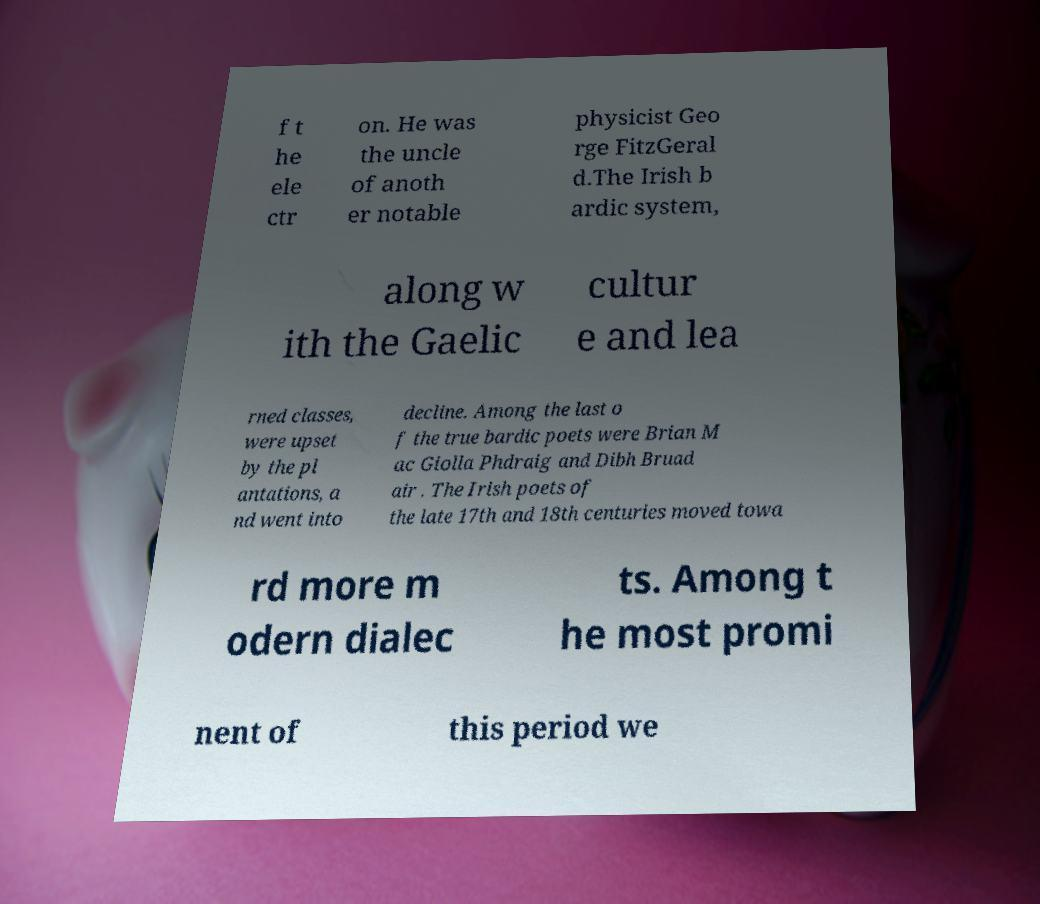For documentation purposes, I need the text within this image transcribed. Could you provide that? f t he ele ctr on. He was the uncle of anoth er notable physicist Geo rge FitzGeral d.The Irish b ardic system, along w ith the Gaelic cultur e and lea rned classes, were upset by the pl antations, a nd went into decline. Among the last o f the true bardic poets were Brian M ac Giolla Phdraig and Dibh Bruad air . The Irish poets of the late 17th and 18th centuries moved towa rd more m odern dialec ts. Among t he most promi nent of this period we 